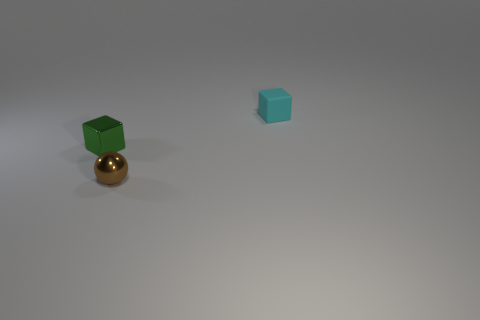Is there a tiny brown ball?
Ensure brevity in your answer.  Yes. There is a sphere; is its color the same as the shiny object behind the brown thing?
Keep it short and to the point. No. The metallic sphere has what color?
Keep it short and to the point. Brown. Is there any other thing that is the same shape as the cyan rubber object?
Keep it short and to the point. Yes. There is another thing that is the same shape as the small matte thing; what color is it?
Provide a succinct answer. Green. Does the green metallic object have the same shape as the tiny rubber object?
Your answer should be compact. Yes. What number of cylinders are either shiny objects or small brown objects?
Your response must be concise. 0. There is a tiny object that is made of the same material as the sphere; what color is it?
Give a very brief answer. Green. Do the block that is in front of the cyan rubber cube and the matte block have the same size?
Ensure brevity in your answer.  Yes. Are the tiny ball and the small cube that is to the right of the tiny metallic cube made of the same material?
Provide a succinct answer. No. 